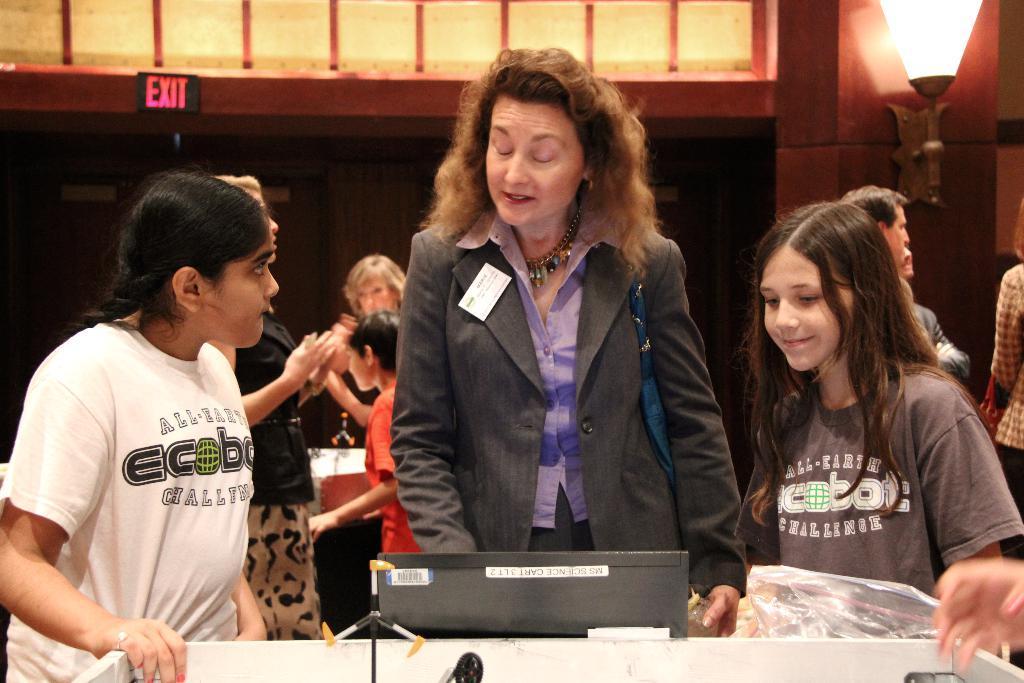Could you give a brief overview of what you see in this image? In this image I can see number of people are standing. I can see most of them are wearing t shirts. Here I can see she is wearing blazer, necklace and I can also see a white colour thing over here. In the background I can see exit board and here I can see few stuffs. 